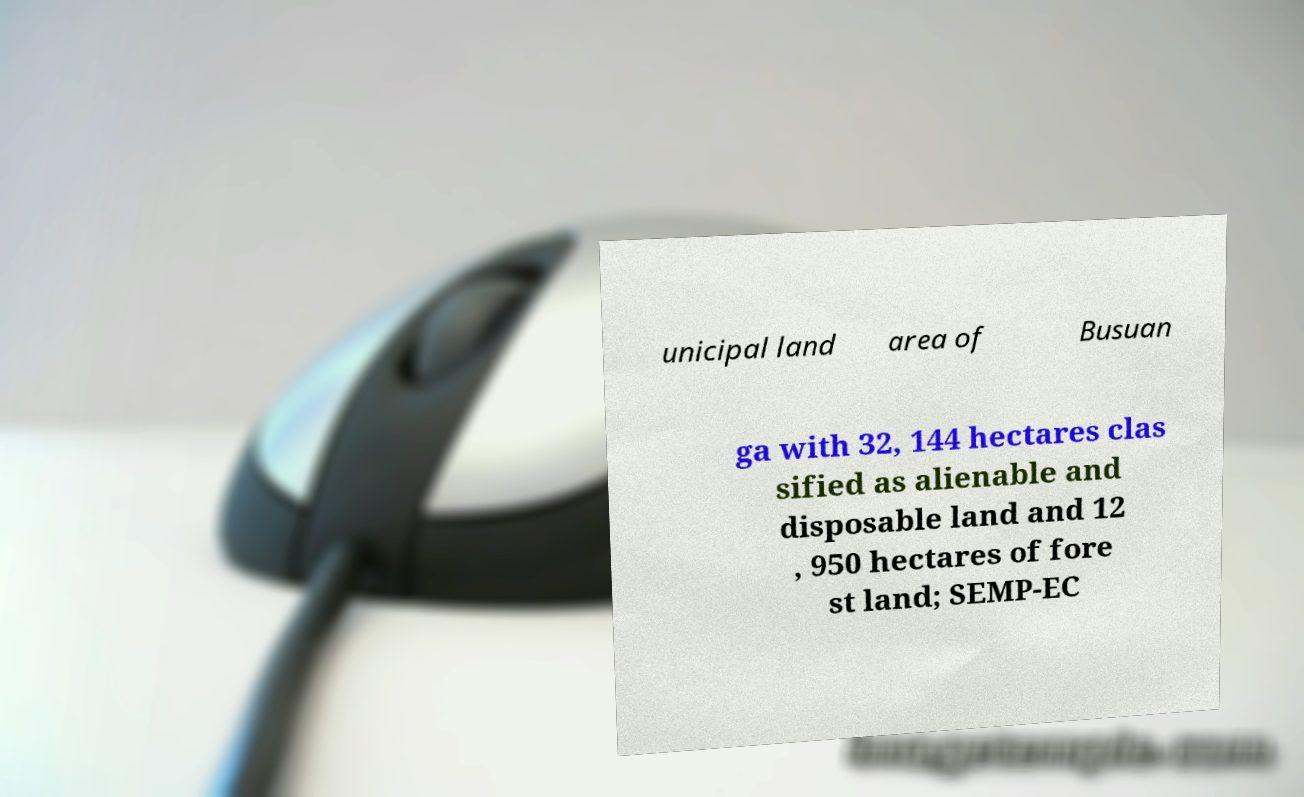Can you accurately transcribe the text from the provided image for me? unicipal land area of Busuan ga with 32, 144 hectares clas sified as alienable and disposable land and 12 , 950 hectares of fore st land; SEMP-EC 